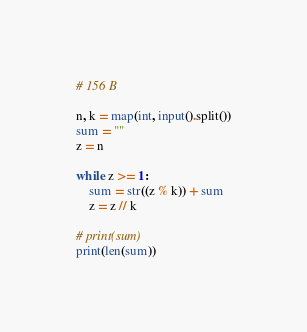Convert code to text. <code><loc_0><loc_0><loc_500><loc_500><_Python_># 156 B  

n, k = map(int, input().split())
sum = ""
z = n

while z >= 1:
    sum = str((z % k)) + sum
    z = z // k

# print(sum)
print(len(sum))</code> 